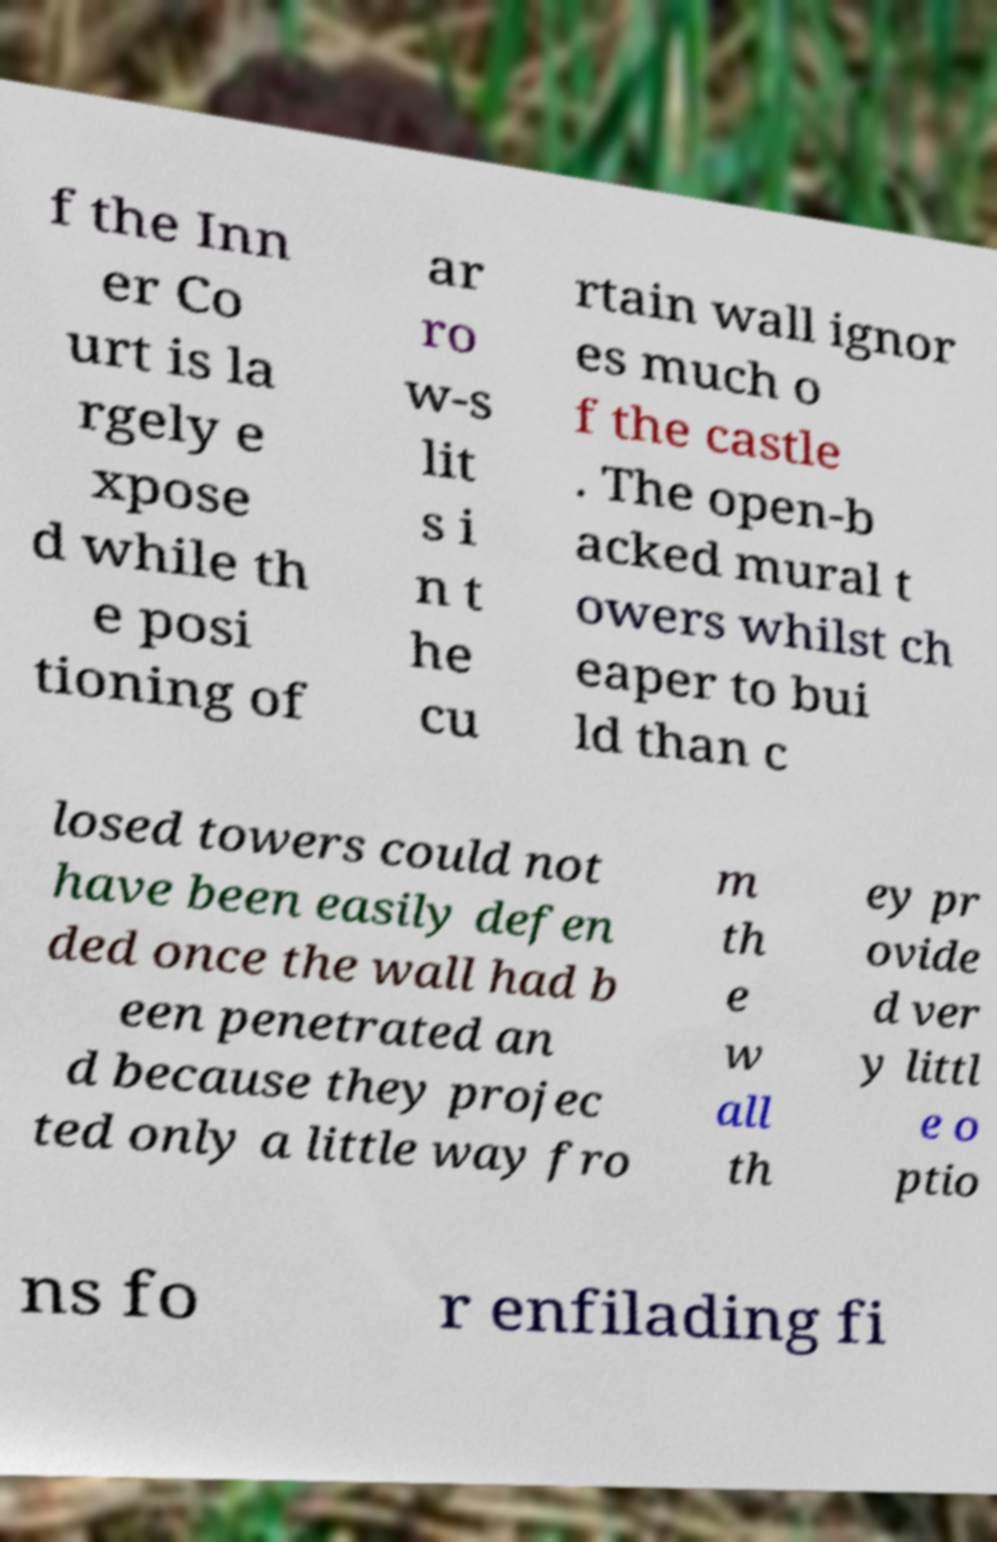Please read and relay the text visible in this image. What does it say? f the Inn er Co urt is la rgely e xpose d while th e posi tioning of ar ro w-s lit s i n t he cu rtain wall ignor es much o f the castle . The open-b acked mural t owers whilst ch eaper to bui ld than c losed towers could not have been easily defen ded once the wall had b een penetrated an d because they projec ted only a little way fro m th e w all th ey pr ovide d ver y littl e o ptio ns fo r enfilading fi 